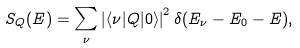<formula> <loc_0><loc_0><loc_500><loc_500>S _ { Q } ( E ) = \sum _ { \nu } \left | \langle \nu | { Q } | 0 \rangle \right | ^ { 2 } \delta ( E _ { \nu } - E _ { 0 } - E ) ,</formula> 